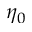<formula> <loc_0><loc_0><loc_500><loc_500>\eta _ { 0 }</formula> 